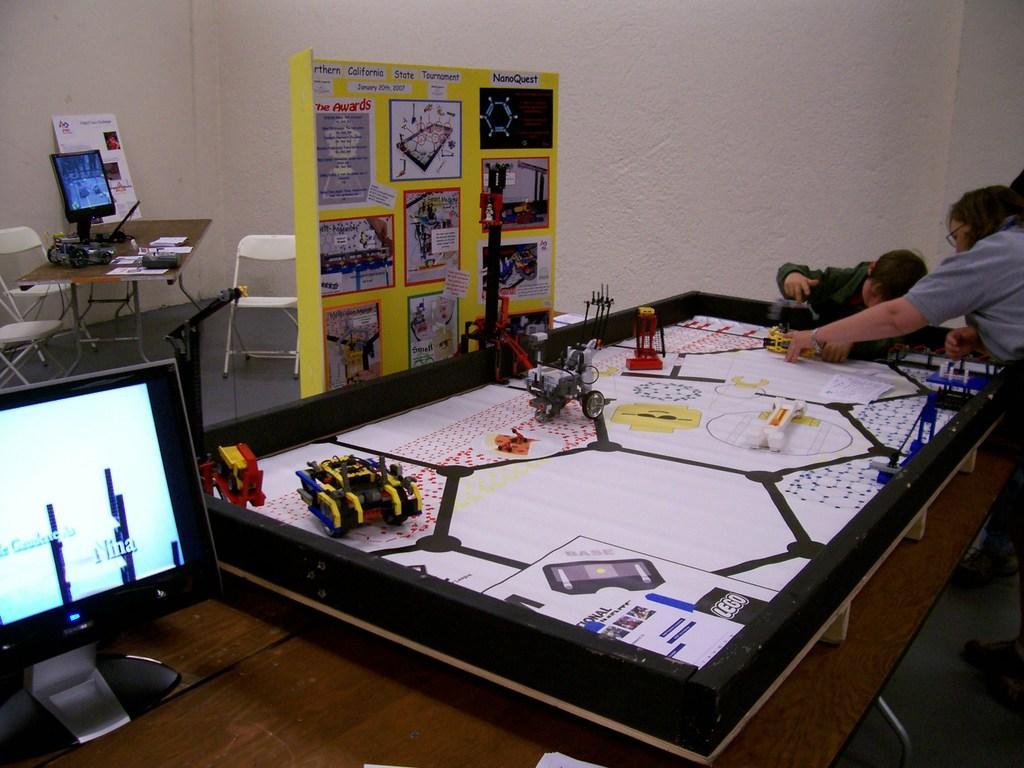In one or two sentences, can you explain what this image depicts? In this image I can see few people and few soft toys on this table. I can also see a monitor over here. In the background I can see number of chairs, a table and one more monitor. 